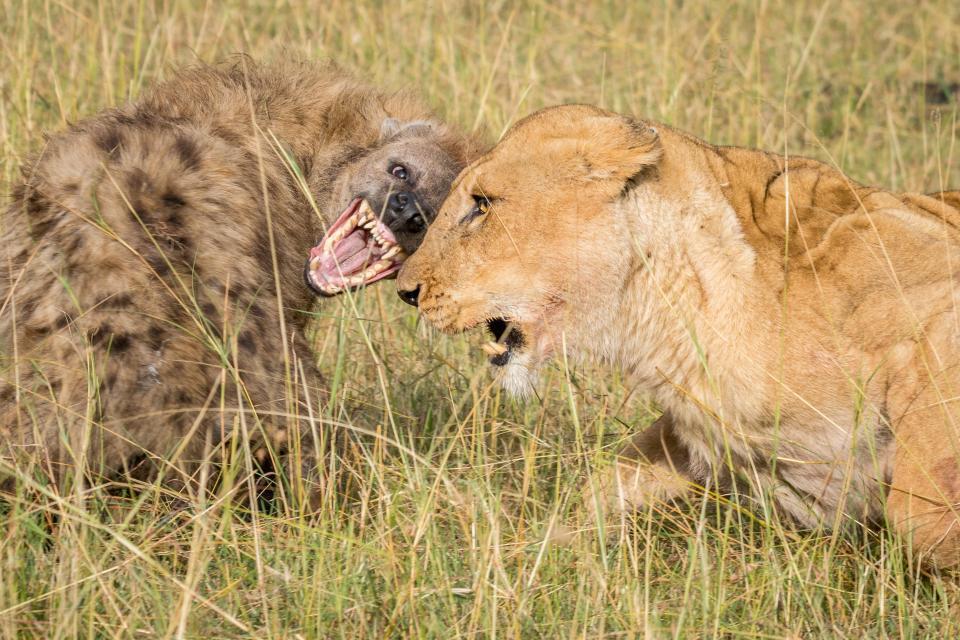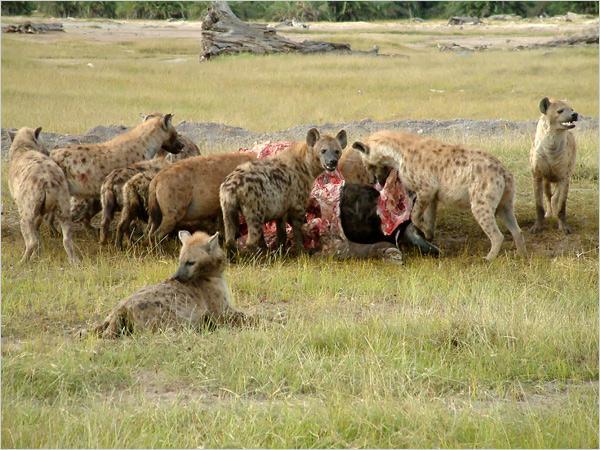The first image is the image on the left, the second image is the image on the right. Examine the images to the left and right. Is the description "One hyena sits while two stand on either side of it." accurate? Answer yes or no. No. The first image is the image on the left, the second image is the image on the right. Evaluate the accuracy of this statement regarding the images: "An open-mouthed lion is near a hyena in one image.". Is it true? Answer yes or no. Yes. 